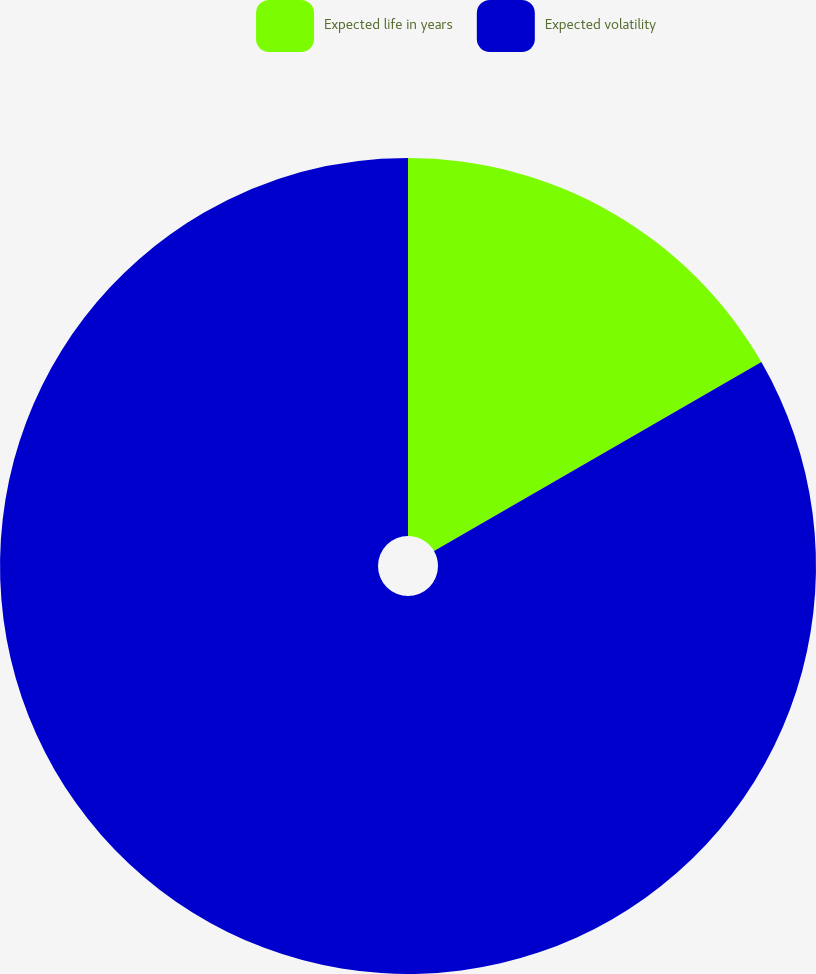Convert chart to OTSL. <chart><loc_0><loc_0><loc_500><loc_500><pie_chart><fcel>Expected life in years<fcel>Expected volatility<nl><fcel>16.67%<fcel>83.33%<nl></chart> 